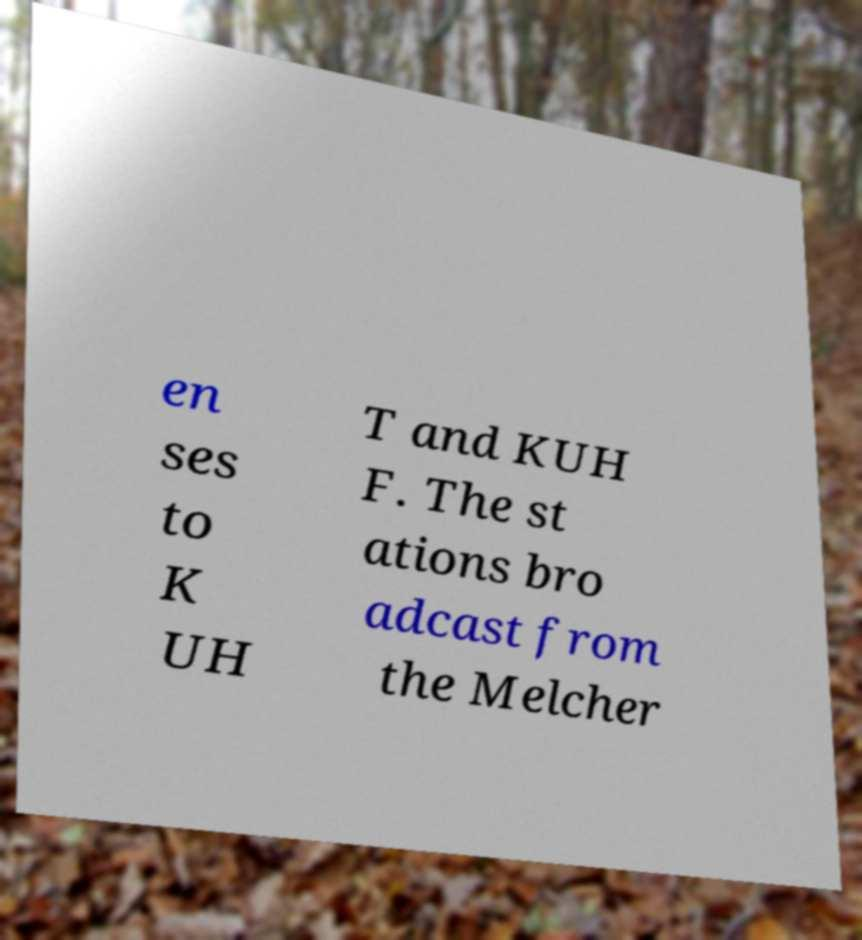Please identify and transcribe the text found in this image. en ses to K UH T and KUH F. The st ations bro adcast from the Melcher 